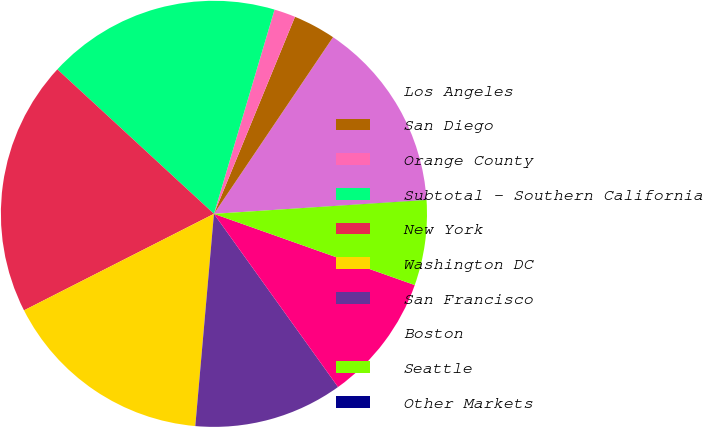Convert chart. <chart><loc_0><loc_0><loc_500><loc_500><pie_chart><fcel>Los Angeles<fcel>San Diego<fcel>Orange County<fcel>Subtotal - Southern California<fcel>New York<fcel>Washington DC<fcel>San Francisco<fcel>Boston<fcel>Seattle<fcel>Other Markets<nl><fcel>14.51%<fcel>3.23%<fcel>1.62%<fcel>17.73%<fcel>19.34%<fcel>16.12%<fcel>11.29%<fcel>9.68%<fcel>6.46%<fcel>0.01%<nl></chart> 